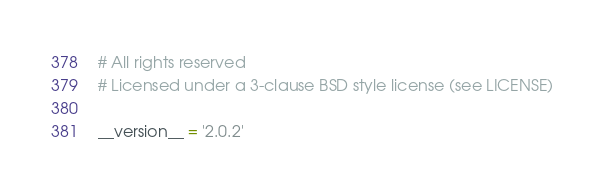Convert code to text. <code><loc_0><loc_0><loc_500><loc_500><_Python_># All rights reserved
# Licensed under a 3-clause BSD style license (see LICENSE)

__version__ = '2.0.2'
</code> 